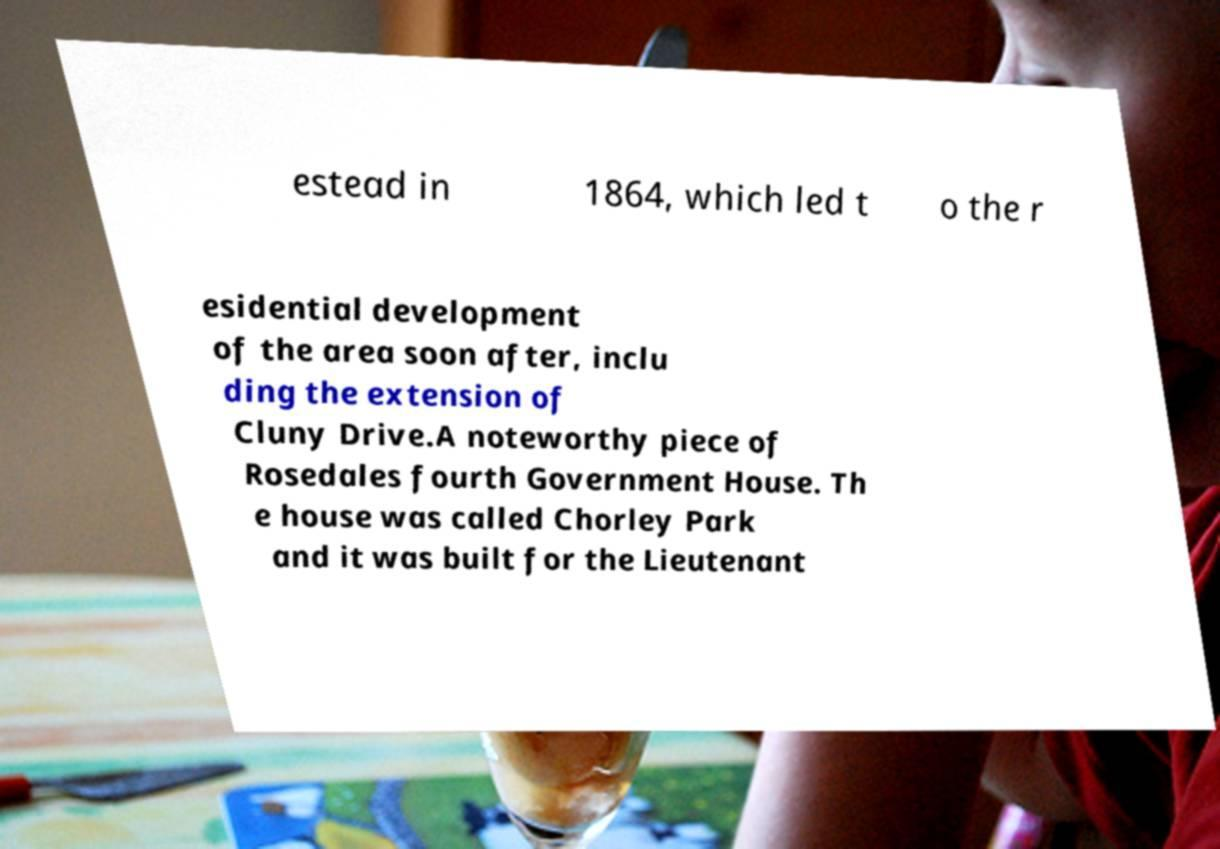Please read and relay the text visible in this image. What does it say? estead in 1864, which led t o the r esidential development of the area soon after, inclu ding the extension of Cluny Drive.A noteworthy piece of Rosedales fourth Government House. Th e house was called Chorley Park and it was built for the Lieutenant 